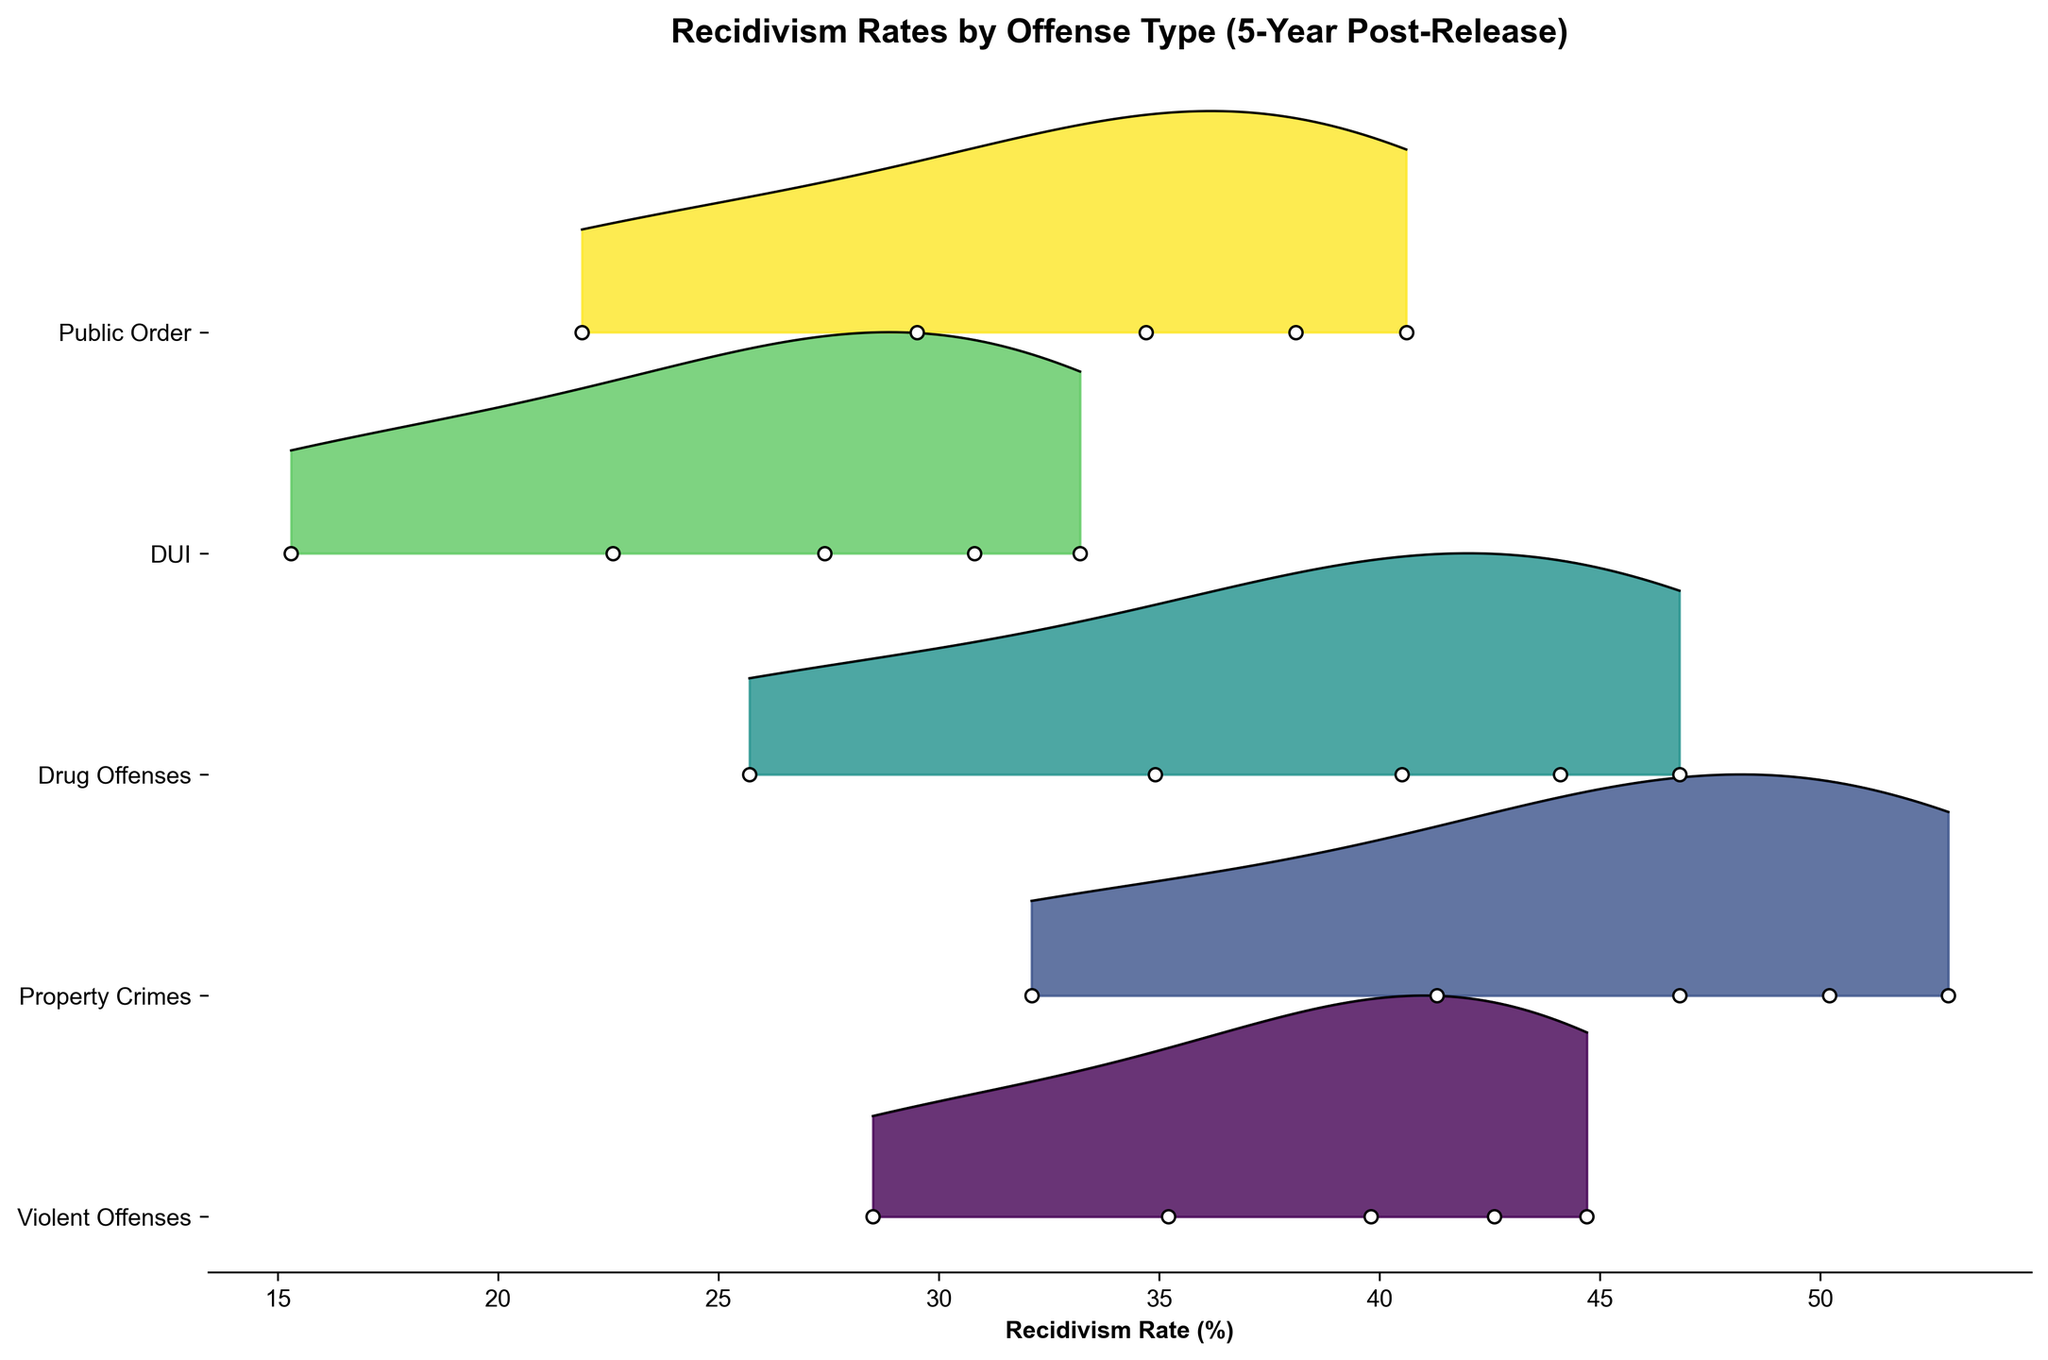What's the highest recidivism rate for violent offenses during the five-year period? The highest recidivism rate for violent offenses can be identified from the rates provided for each year. By looking at the plot, the highest rate is observed in year 5.
Answer: 44.7% What is the title of the plot? The title of the plot is written at the top of the figure and describes what the plot represents.
Answer: Recidivism Rates by Offense Type (5-Year Post-Release) Which offense type has the lowest recidivism rate by year 1? By examining the figure, we look at year 1 and identify the lowest recidivism rate among all offenses. DUI has the lowest rate in year 1.
Answer: DUI What is the difference in the year 5 recidivism rate between Property Crimes and Public Order offenses? Compare the year 5 recidivism rates for Property Crimes and Public Order. Property Crimes have a recidivism rate of 52.9% and Public Order has 40.6%. The difference can be calculated as 52.9 - 40.6.
Answer: 12.3% How do the recidivism rates for Drug Offenses change from year 1 to year 5? Look at the recidivism rates for Drug Offenses at year 1 and year 5. Year 1 rate is 25.7%, and year 5 rate is 46.8%. This means there is an increase from year 1 to year 5.
Answer: Increase Which offense type shows the steepest increase in recidivism rates over the five years? Identify the offense type with the greatest change from year 1 to year 5. Calculating the increase for each, Property Crimes (32.1% to 52.9%) shows the steepest increase of 20.8%.
Answer: Property Crimes Do Public Order offenses consistently show a lower or higher recidivism rate compared to Drug Offenses through the years? By comparing the recidivism rates year by year, we observe that Public Order offenses consistently have lower recidivism rates than Drug Offenses from year 1 to year 5.
Answer: Lower What is the color pattern used to differentiate the offense types in the plot? The plot uses a gradient color scheme to differentiate the offenses, where each type is represented by a unique shade from the color palette.
Answer: Gradient color scheme What is the median recidivism rate for all offenses combined in year 3? Identify all recidivism rates for year 3, which are 39.8%, 46.8%, 40.5%, 27.4%, and 34.7%. Ordering these values: 27.4%, 34.7%, 39.8%, 40.5%, 46.8%, the middle value is 39.8%.
Answer: 39.8% 